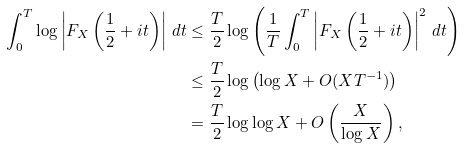<formula> <loc_0><loc_0><loc_500><loc_500>\int _ { 0 } ^ { T } \log \left | F _ { X } \left ( \frac { 1 } { 2 } + i t \right ) \right | \, d t & \leq \frac { T } { 2 } \log \left ( \frac { 1 } { T } \int _ { 0 } ^ { T } \left | F _ { X } \left ( \frac { 1 } { 2 } + i t \right ) \right | ^ { 2 } \, d t \right ) \\ & \leq \frac { T } { 2 } \log \left ( \log X + O ( X T ^ { - 1 } ) \right ) \\ & = \frac { T } { 2 } \log \log X + O \left ( \frac { X } { \log X } \right ) ,</formula> 